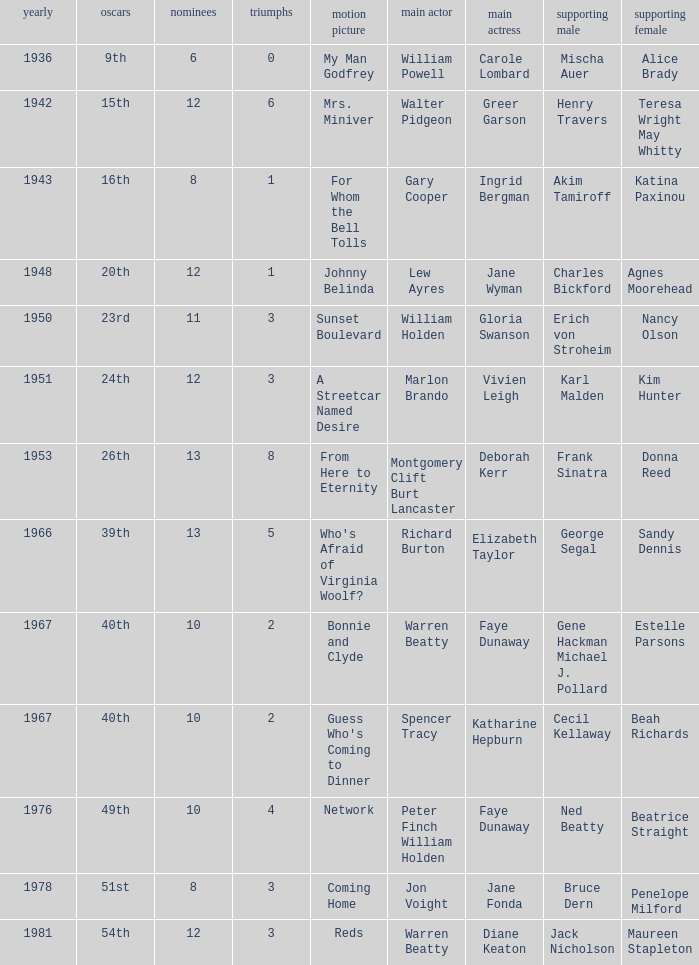Who was the leading actress in a film with Warren Beatty as the leading actor and also at the 40th Oscars? Faye Dunaway. 